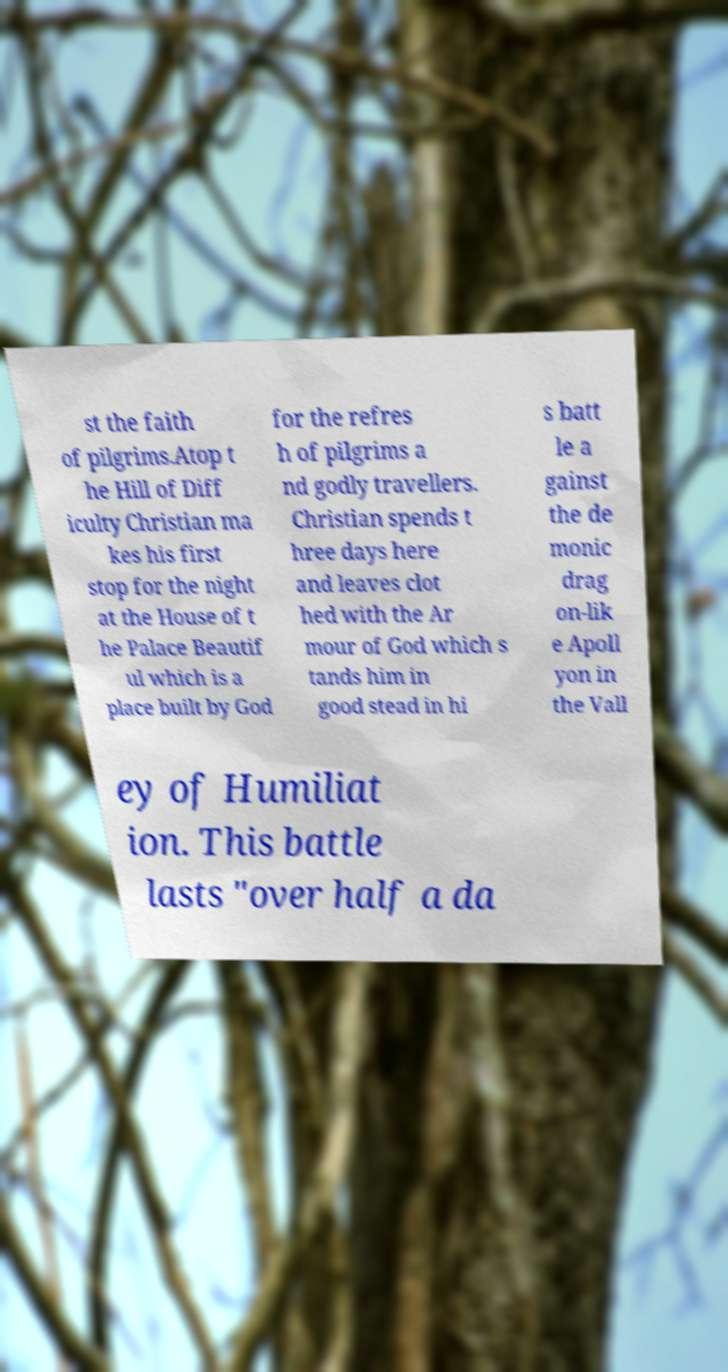Please identify and transcribe the text found in this image. st the faith of pilgrims.Atop t he Hill of Diff iculty Christian ma kes his first stop for the night at the House of t he Palace Beautif ul which is a place built by God for the refres h of pilgrims a nd godly travellers. Christian spends t hree days here and leaves clot hed with the Ar mour of God which s tands him in good stead in hi s batt le a gainst the de monic drag on-lik e Apoll yon in the Vall ey of Humiliat ion. This battle lasts "over half a da 